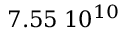<formula> <loc_0><loc_0><loc_500><loc_500>7 . 5 5 \, 1 0 ^ { 1 0 }</formula> 